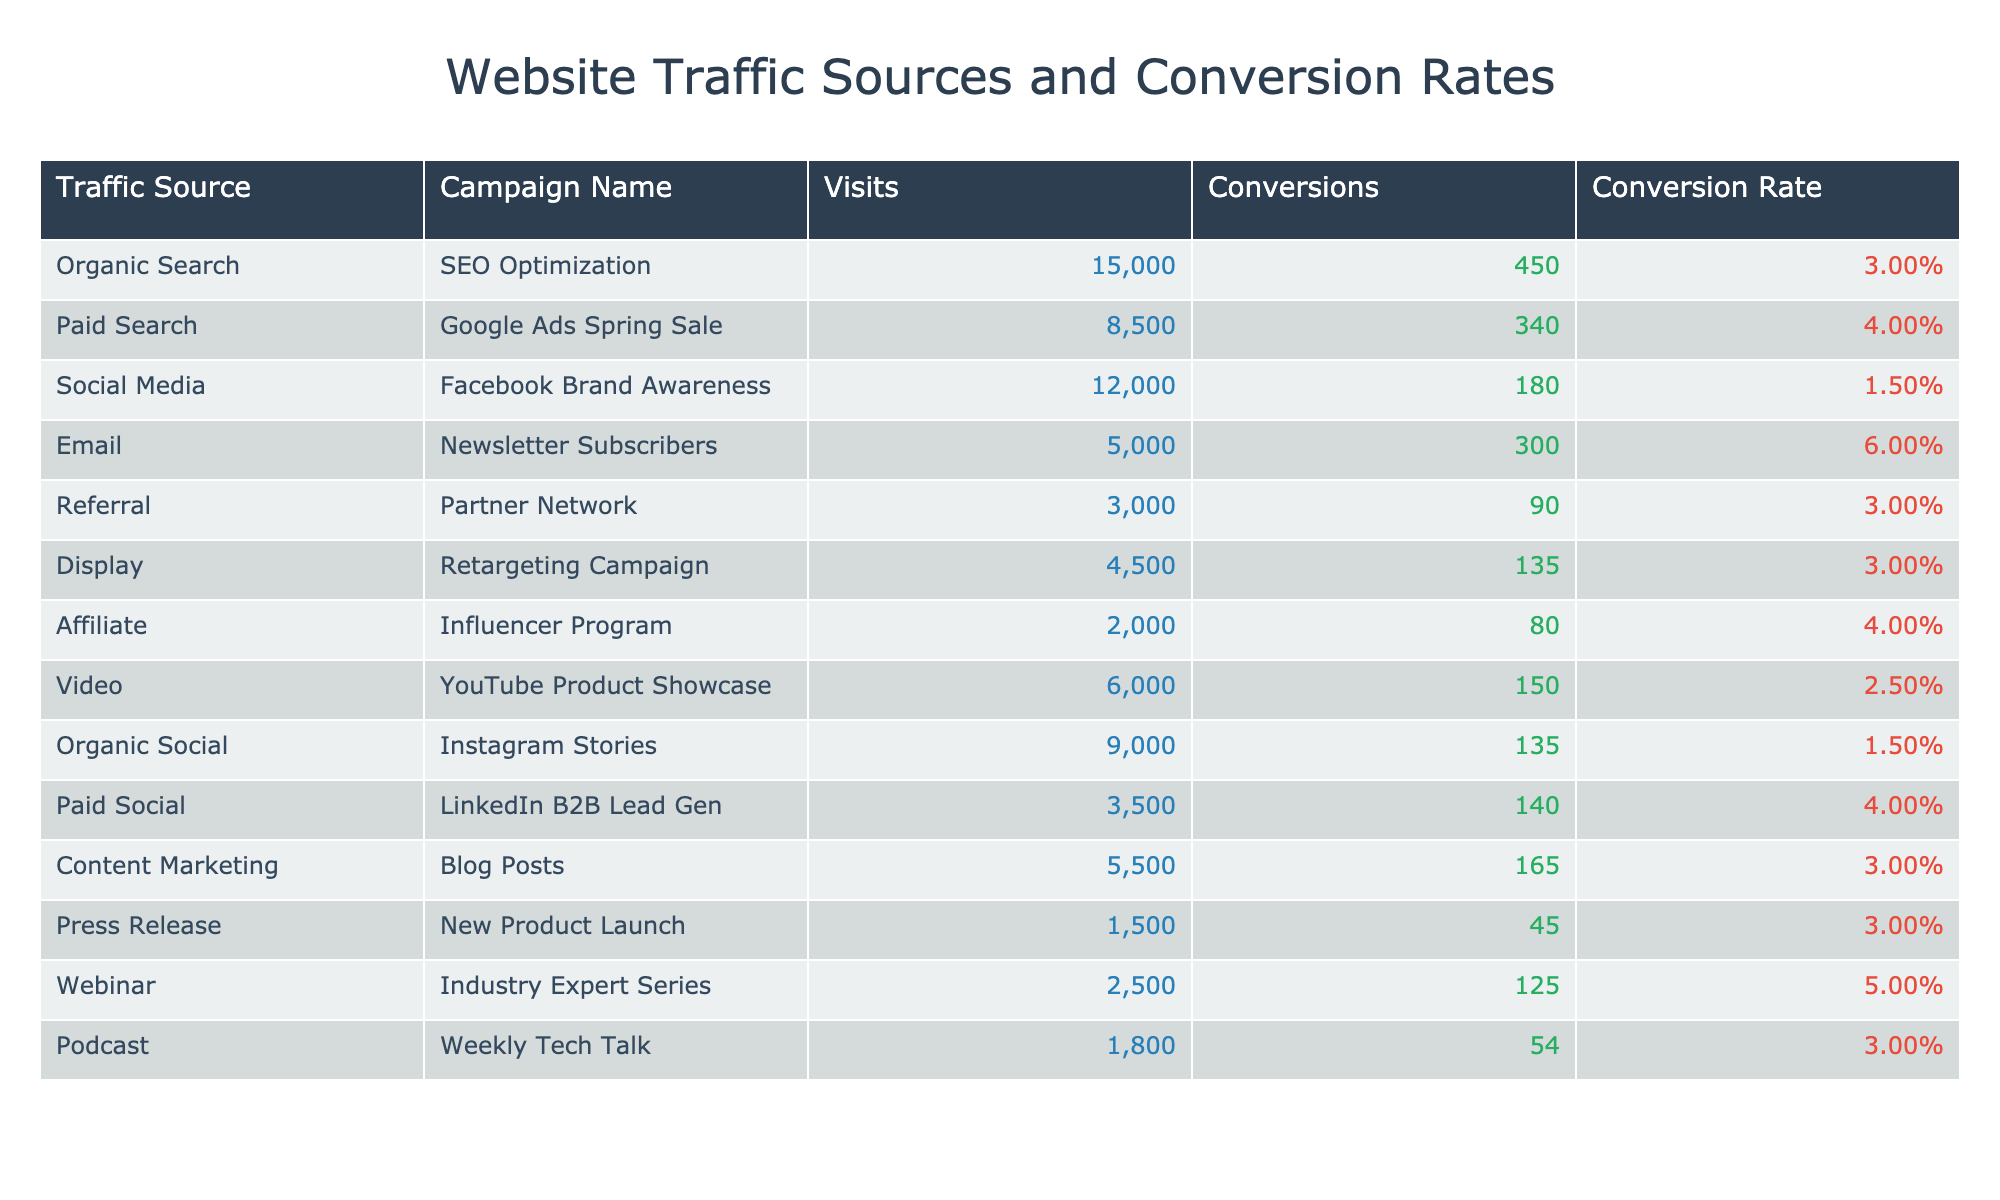What is the conversion rate for the Email campaign? Referring to the table, the conversion rate for the Email campaign (Newsletter Subscribers) is listed directly in the table. It shows a conversion rate of 6.00%.
Answer: 6.00% Which traffic source had the highest number of visits? Looking at the Visits column, we find that the Organic Search traffic source had the most visits, totaling 15,000.
Answer: Organic Search What is the total number of conversions from all traffic sources? To find the total conversions, we need to sum up all the conversions from the Conversions column: 450 + 340 + 180 + 300 + 90 + 135 + 80 + 150 + 135 + 140 + 165 + 45 + 125 + 54 = 2,054.
Answer: 2054 Which traffic source generated the lowest conversion rate? Comparing the Conversion Rate column, the Social Media traffic source (Facebook Brand Awareness) has the lowest conversion rate at 1.50%.
Answer: Social Media Is there any traffic source with a conversion rate higher than 5%? Checking the Conversion Rate column, the Email (6.00%) and Webinar (5.00%) campaigns show conversion rates higher than 5%. The condition is met.
Answer: Yes What is the average conversion rate across all traffic sources? To calculate the average conversion rate, first, convert each rate to decimal: (3.00% + 4.00% + 1.50% + 6.00% + 3.00% + 3.00% + 4.00% + 2.50% + 1.50% + 4.00% + 3.00% + 3.00% + 5.00% + 3.00%)/14 = 3.36%, giving us an average conversion rate.
Answer: 3.36% Which marketing campaign resulted in the highest conversion? By checking the Conversions column, the Email campaign (Newsletter Subscribers) achieved the highest number of conversions, totaling 300.
Answer: Email What is the difference in conversion rates between the highest and lowest converting traffic sources? The highest conversion rate is 6.00% (Email) and the lowest is 1.50% (Social Media). The difference is 6.00% - 1.50% = 4.50%.
Answer: 4.50% Which traffic source had a total of 4,500 visits? Inspecting the Visits column, the Display traffic source for the Retargeting Campaign shows a total of 4,500 visits.
Answer: Display Is the conversion rate of the Affiliate traffic source higher than that of the Display source? The Affiliate traffic source has a conversion rate of 4.00%, while the Display source has a conversion rate of 3.00%. Since 4.00% > 3.00%, the statement is true.
Answer: Yes Which two campaigns had the same number of visits? Upon examining the Visits column, both the Paid Social (3,500 visits) and Video (6,000 visits) campaigns had unique visit numbers after careful review, meaning none share the same visits.
Answer: None 